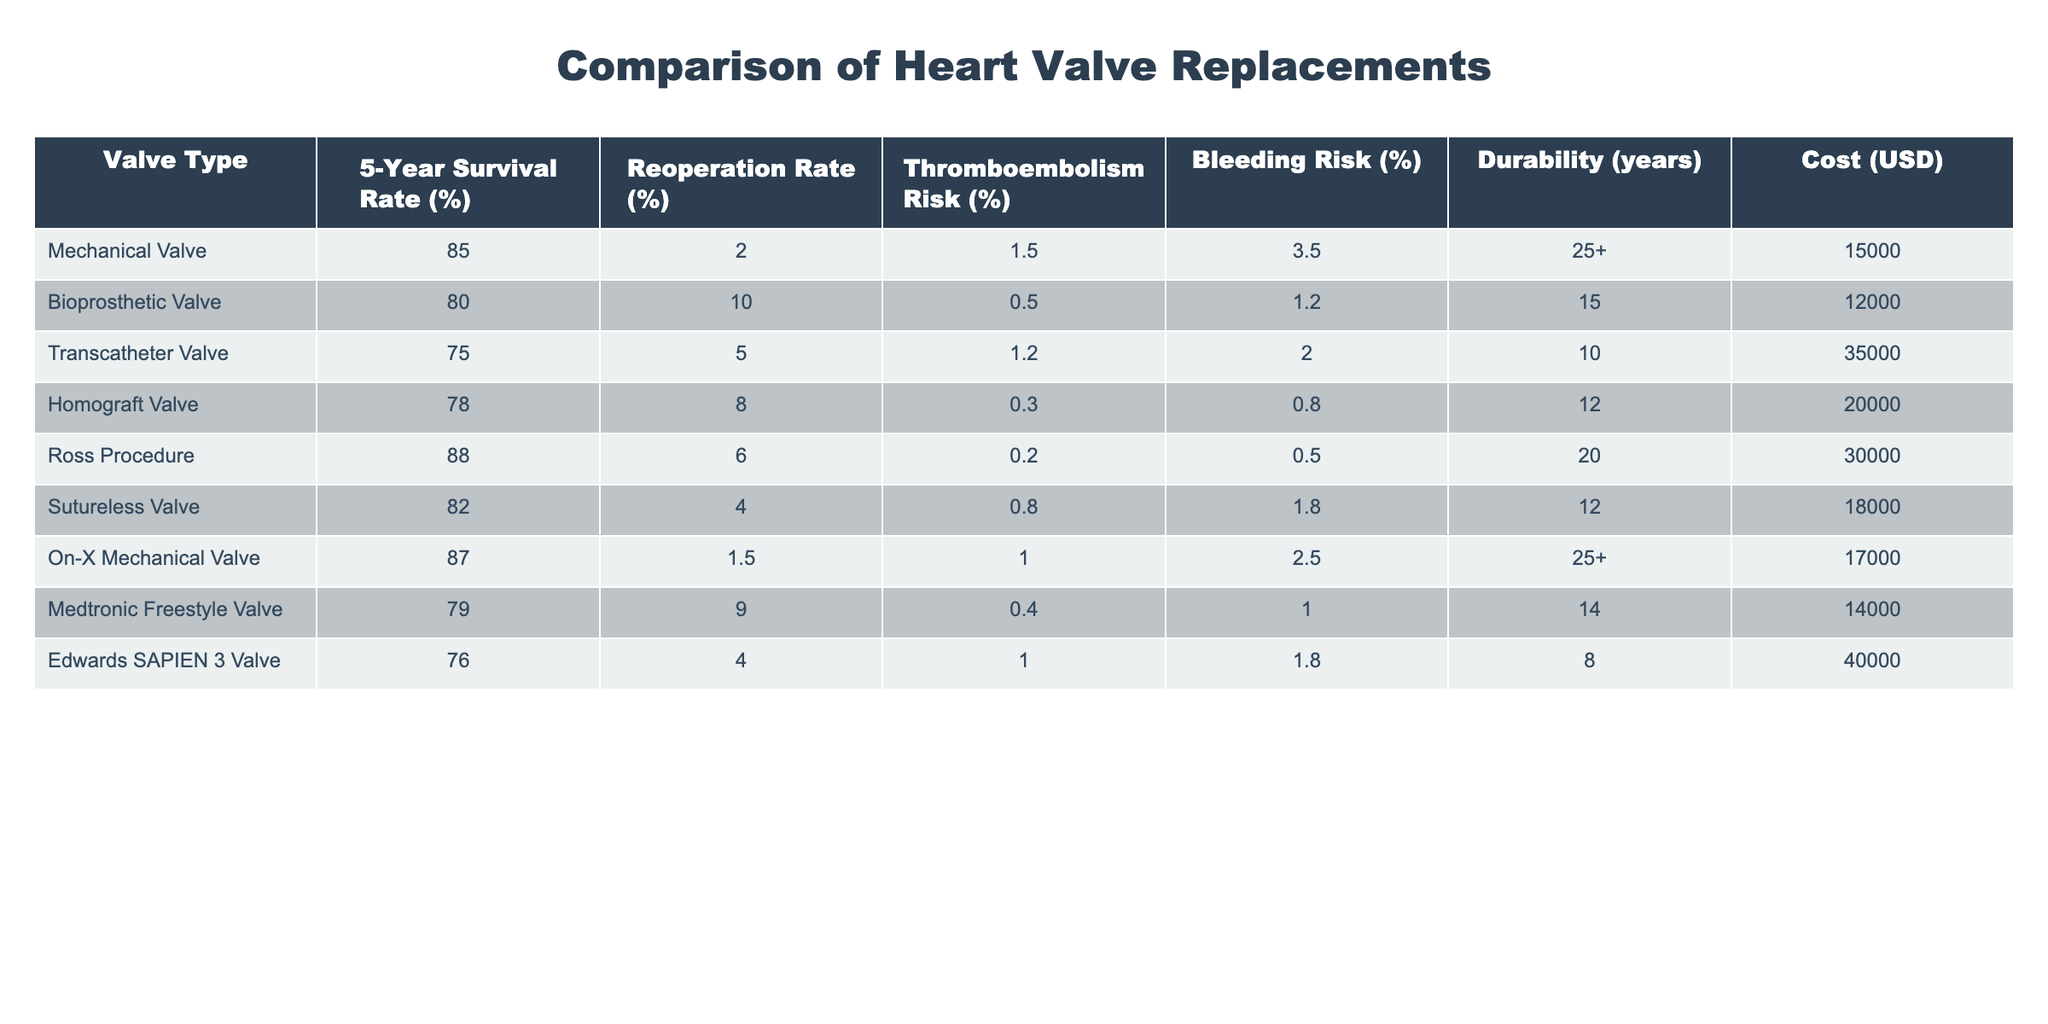What is the 5-year survival rate for the Ross Procedure? The table indicates that the 5-year survival rate for the Ross Procedure is 88%.
Answer: 88% Which valve type has the lowest reoperation rate? According to the table, the On-X Mechanical Valve has the lowest reoperation rate at 1.5%.
Answer: 1.5% What is the average durability of the bioprosthetic valves listed? The bioprosthetic valves listed are the Bioprosthetic Valve and the Medtronic Freestyle Valve. Their durabilities are 15 and 14 years, respectively. The average durability is (15 + 14) / 2 = 14.5 years.
Answer: 14.5 years Is the thromboembolism risk higher for the Transcatheter Valve compared to the Bioprosthetic Valve? The Transcatheter Valve has a thromboembolism risk of 1.2%, while the Bioprosthetic Valve has a risk of 0.5%. Since 1.2% is greater than 0.5%, the statement is true.
Answer: Yes What is the cost difference between the Edwards SAPIEN 3 Valve and the Ross Procedure? The cost of the Edwards SAPIEN 3 Valve is $40,000 and the cost of the Ross Procedure is $30,000. The difference is $40,000 - $30,000 = $10,000.
Answer: $10,000 If we consider the bleeding risk, which valve has the highest and which has the lowest? The table shows that the Mechanical Valve has a bleeding risk of 3.5%, which is the highest. The Homograft Valve has the lowest bleeding risk of 0.8%.
Answer: Highest: 3.5%, Lowest: 0.8% How many valve types have a survival rate of 80% or lower? The types with a survival rate of 80% or lower are the Bioprosthetic Valve (80%), Transcatheter Valve (75%), and Edwards SAPIEN 3 Valve (76%). There are 3 valve types in this category.
Answer: 3 What is the combined reoperation rate of the Sutureless Valve and the On-X Mechanical Valve? The reoperation rates are 4% for the Sutureless Valve and 1.5% for the On-X Mechanical Valve. Adding these gives a combined rate of 4 + 1.5 = 5.5%.
Answer: 5.5% Which valve offers the best durability? The Mechanical Valve and On-X Mechanical Valve both have a durability of 25+ years, which is the best among the options provided.
Answer: 25+ years Is the cost of the Transcatheter Valve higher than the cost of the Sutureless Valve? The Transcatheter Valve costs $35,000, while the Sutureless Valve costs $18,000. Since $35,000 is higher than $18,000, the statement is true.
Answer: Yes 